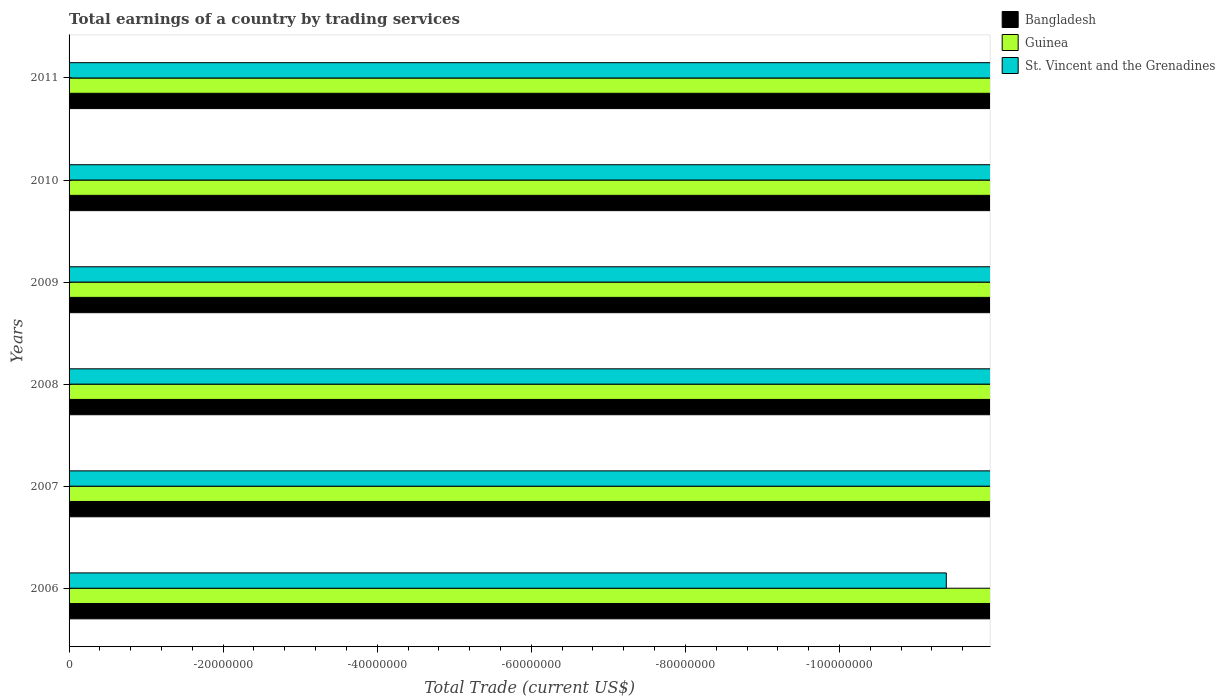How many different coloured bars are there?
Your answer should be very brief. 0. How many bars are there on the 1st tick from the bottom?
Ensure brevity in your answer.  0. In how many cases, is the number of bars for a given year not equal to the number of legend labels?
Offer a terse response. 6. Across all years, what is the minimum total earnings in Bangladesh?
Provide a succinct answer. 0. What is the total total earnings in Bangladesh in the graph?
Make the answer very short. 0. What is the difference between the total earnings in St. Vincent and the Grenadines in 2010 and the total earnings in Guinea in 2011?
Your response must be concise. 0. How many bars are there?
Give a very brief answer. 0. Are all the bars in the graph horizontal?
Provide a short and direct response. Yes. How many years are there in the graph?
Your answer should be compact. 6. Does the graph contain any zero values?
Your answer should be very brief. Yes. How many legend labels are there?
Offer a terse response. 3. What is the title of the graph?
Your answer should be compact. Total earnings of a country by trading services. Does "Norway" appear as one of the legend labels in the graph?
Offer a very short reply. No. What is the label or title of the X-axis?
Your answer should be very brief. Total Trade (current US$). What is the label or title of the Y-axis?
Ensure brevity in your answer.  Years. What is the Total Trade (current US$) in Bangladesh in 2006?
Your answer should be very brief. 0. What is the Total Trade (current US$) of Guinea in 2006?
Your response must be concise. 0. What is the Total Trade (current US$) in St. Vincent and the Grenadines in 2006?
Ensure brevity in your answer.  0. What is the Total Trade (current US$) in St. Vincent and the Grenadines in 2007?
Provide a short and direct response. 0. What is the Total Trade (current US$) in St. Vincent and the Grenadines in 2009?
Provide a short and direct response. 0. What is the Total Trade (current US$) of St. Vincent and the Grenadines in 2010?
Ensure brevity in your answer.  0. What is the Total Trade (current US$) in Bangladesh in 2011?
Provide a short and direct response. 0. What is the total Total Trade (current US$) in Bangladesh in the graph?
Give a very brief answer. 0. What is the total Total Trade (current US$) of St. Vincent and the Grenadines in the graph?
Provide a short and direct response. 0. What is the average Total Trade (current US$) in Bangladesh per year?
Provide a succinct answer. 0. 